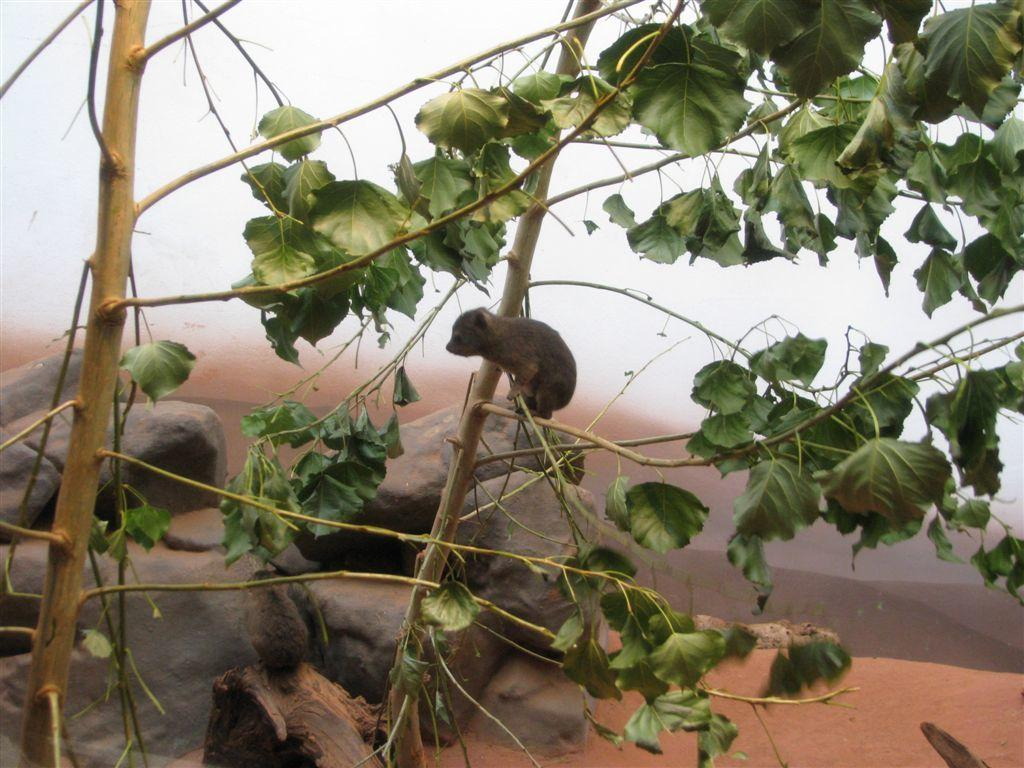What type of animal is in the image? There is a rodent in the image. Where is the rodent located? The rodent is on the branches of a plant. What else can be seen in the image besides the rodent? There are rock stones visible in the image. What is the temperature of the machine in the image? There is no machine present in the image, so it is not possible to determine its temperature. 